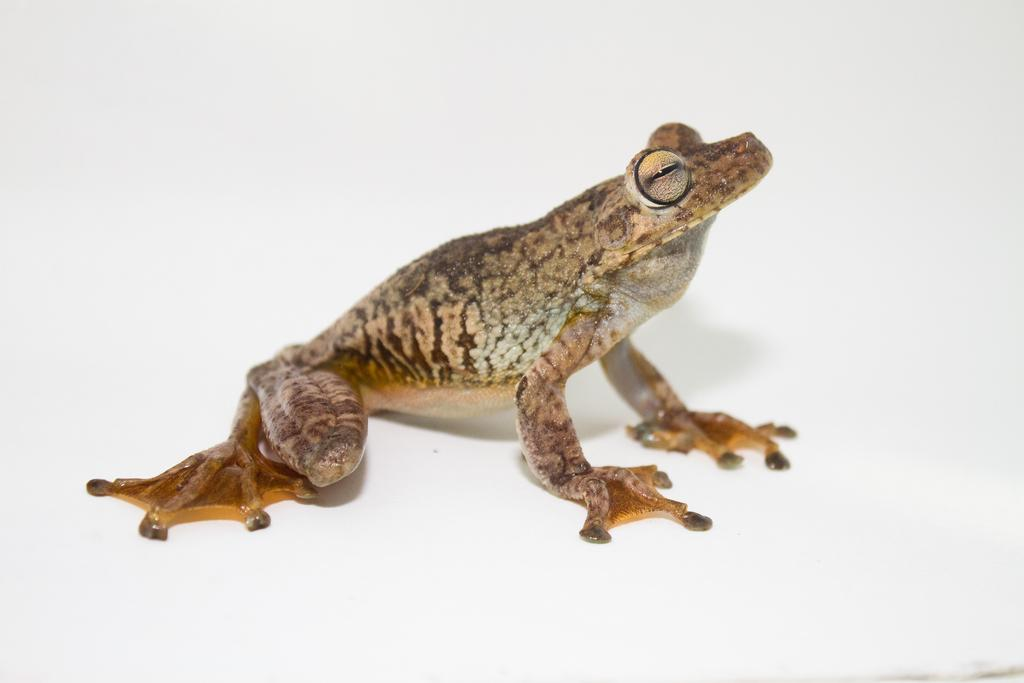What animal is present in the image? There is a frog in the image. What color is the background of the image? The background of the image is white. Who is the expert in the image? There is no expert present in the image; it features a frog against a white background. How many crows can be seen in the image? There are no crows present in the image; it features a frog against a white background. 